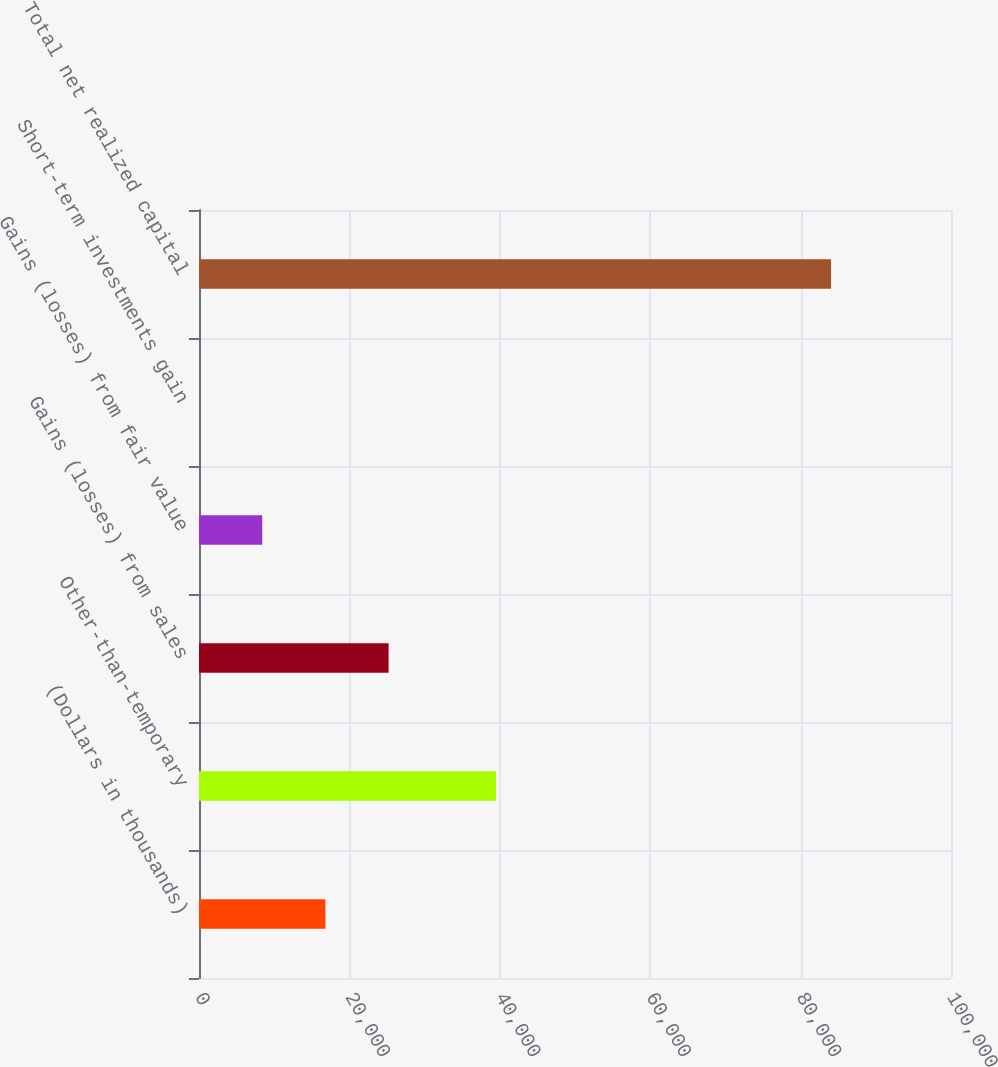Convert chart. <chart><loc_0><loc_0><loc_500><loc_500><bar_chart><fcel>(Dollars in thousands)<fcel>Other-than-temporary<fcel>Gains (losses) from sales<fcel>Gains (losses) from fair value<fcel>Short-term investments gain<fcel>Total net realized capital<nl><fcel>16811.6<fcel>39502<fcel>25215.9<fcel>8407.3<fcel>3<fcel>84046<nl></chart> 